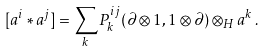Convert formula to latex. <formula><loc_0><loc_0><loc_500><loc_500>[ a ^ { i } * a ^ { j } ] = \sum _ { k } P ^ { i j } _ { k } ( \partial \otimes 1 , 1 \otimes \partial ) \otimes _ { H } a ^ { k } \, .</formula> 